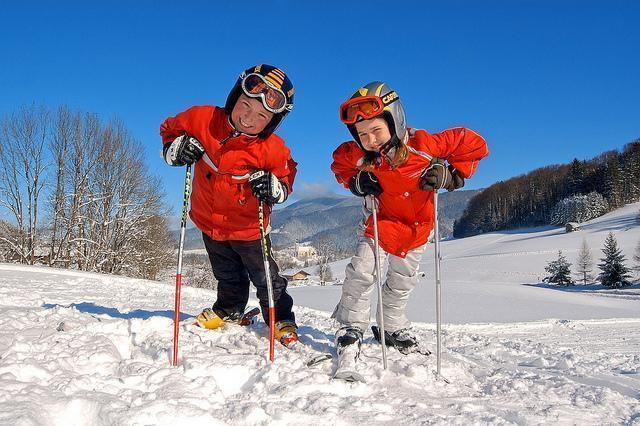Where is most of the kids weight?
Choose the right answer from the provided options to respond to the question.
Options: On heads, on feet, on arms, on skis. On skis. 